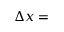<formula> <loc_0><loc_0><loc_500><loc_500>\Delta x =</formula> 